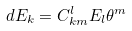Convert formula to latex. <formula><loc_0><loc_0><loc_500><loc_500>d E _ { k } = C _ { k m } ^ { l } E _ { l } \theta ^ { m }</formula> 